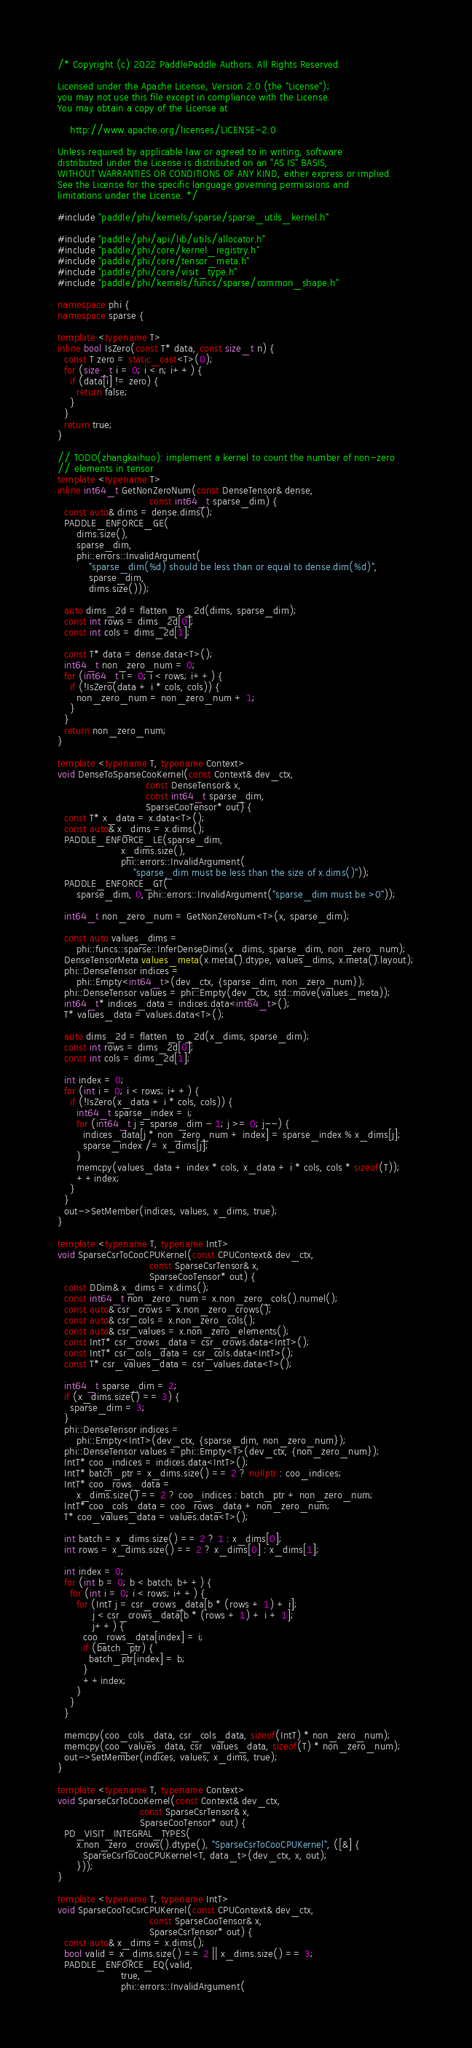<code> <loc_0><loc_0><loc_500><loc_500><_C++_>/* Copyright (c) 2022 PaddlePaddle Authors. All Rights Reserved.

Licensed under the Apache License, Version 2.0 (the "License");
you may not use this file except in compliance with the License.
You may obtain a copy of the License at

    http://www.apache.org/licenses/LICENSE-2.0

Unless required by applicable law or agreed to in writing, software
distributed under the License is distributed on an "AS IS" BASIS,
WITHOUT WARRANTIES OR CONDITIONS OF ANY KIND, either express or implied.
See the License for the specific language governing permissions and
limitations under the License. */

#include "paddle/phi/kernels/sparse/sparse_utils_kernel.h"

#include "paddle/phi/api/lib/utils/allocator.h"
#include "paddle/phi/core/kernel_registry.h"
#include "paddle/phi/core/tensor_meta.h"
#include "paddle/phi/core/visit_type.h"
#include "paddle/phi/kernels/funcs/sparse/common_shape.h"

namespace phi {
namespace sparse {

template <typename T>
inline bool IsZero(const T* data, const size_t n) {
  const T zero = static_cast<T>(0);
  for (size_t i = 0; i < n; i++) {
    if (data[i] != zero) {
      return false;
    }
  }
  return true;
}

// TODO(zhangkaihuo): implement a kernel to count the number of non-zero
// elements in tensor
template <typename T>
inline int64_t GetNonZeroNum(const DenseTensor& dense,
                             const int64_t sparse_dim) {
  const auto& dims = dense.dims();
  PADDLE_ENFORCE_GE(
      dims.size(),
      sparse_dim,
      phi::errors::InvalidArgument(
          "sparse_dim(%d) should be less than or equal to dense.dim(%d)",
          sparse_dim,
          dims.size()));

  auto dims_2d = flatten_to_2d(dims, sparse_dim);
  const int rows = dims_2d[0];
  const int cols = dims_2d[1];

  const T* data = dense.data<T>();
  int64_t non_zero_num = 0;
  for (int64_t i = 0; i < rows; i++) {
    if (!IsZero(data + i * cols, cols)) {
      non_zero_num = non_zero_num + 1;
    }
  }
  return non_zero_num;
}

template <typename T, typename Context>
void DenseToSparseCooKernel(const Context& dev_ctx,
                            const DenseTensor& x,
                            const int64_t sparse_dim,
                            SparseCooTensor* out) {
  const T* x_data = x.data<T>();
  const auto& x_dims = x.dims();
  PADDLE_ENFORCE_LE(sparse_dim,
                    x_dims.size(),
                    phi::errors::InvalidArgument(
                        "sparse_dim must be less than the size of x.dims()"));
  PADDLE_ENFORCE_GT(
      sparse_dim, 0, phi::errors::InvalidArgument("sparse_dim must be >0"));

  int64_t non_zero_num = GetNonZeroNum<T>(x, sparse_dim);

  const auto values_dims =
      phi::funcs::sparse::InferDenseDims(x_dims, sparse_dim, non_zero_num);
  DenseTensorMeta values_meta(x.meta().dtype, values_dims, x.meta().layout);
  phi::DenseTensor indices =
      phi::Empty<int64_t>(dev_ctx, {sparse_dim, non_zero_num});
  phi::DenseTensor values = phi::Empty(dev_ctx, std::move(values_meta));
  int64_t* indices_data = indices.data<int64_t>();
  T* values_data = values.data<T>();

  auto dims_2d = flatten_to_2d(x_dims, sparse_dim);
  const int rows = dims_2d[0];
  const int cols = dims_2d[1];

  int index = 0;
  for (int i = 0; i < rows; i++) {
    if (!IsZero(x_data + i * cols, cols)) {
      int64_t sparse_index = i;
      for (int64_t j = sparse_dim - 1; j >= 0; j--) {
        indices_data[j * non_zero_num + index] = sparse_index % x_dims[j];
        sparse_index /= x_dims[j];
      }
      memcpy(values_data + index * cols, x_data + i * cols, cols * sizeof(T));
      ++index;
    }
  }
  out->SetMember(indices, values, x_dims, true);
}

template <typename T, typename IntT>
void SparseCsrToCooCPUKernel(const CPUContext& dev_ctx,
                             const SparseCsrTensor& x,
                             SparseCooTensor* out) {
  const DDim& x_dims = x.dims();
  const int64_t non_zero_num = x.non_zero_cols().numel();
  const auto& csr_crows = x.non_zero_crows();
  const auto& csr_cols = x.non_zero_cols();
  const auto& csr_values = x.non_zero_elements();
  const IntT* csr_crows_data = csr_crows.data<IntT>();
  const IntT* csr_cols_data = csr_cols.data<IntT>();
  const T* csr_values_data = csr_values.data<T>();

  int64_t sparse_dim = 2;
  if (x_dims.size() == 3) {
    sparse_dim = 3;
  }
  phi::DenseTensor indices =
      phi::Empty<IntT>(dev_ctx, {sparse_dim, non_zero_num});
  phi::DenseTensor values = phi::Empty<T>(dev_ctx, {non_zero_num});
  IntT* coo_indices = indices.data<IntT>();
  IntT* batch_ptr = x_dims.size() == 2 ? nullptr : coo_indices;
  IntT* coo_rows_data =
      x_dims.size() == 2 ? coo_indices : batch_ptr + non_zero_num;
  IntT* coo_cols_data = coo_rows_data + non_zero_num;
  T* coo_values_data = values.data<T>();

  int batch = x_dims.size() == 2 ? 1 : x_dims[0];
  int rows = x_dims.size() == 2 ? x_dims[0] : x_dims[1];

  int index = 0;
  for (int b = 0; b < batch; b++) {
    for (int i = 0; i < rows; i++) {
      for (IntT j = csr_crows_data[b * (rows + 1) + i];
           j < csr_crows_data[b * (rows + 1) + i + 1];
           j++) {
        coo_rows_data[index] = i;
        if (batch_ptr) {
          batch_ptr[index] = b;
        }
        ++index;
      }
    }
  }

  memcpy(coo_cols_data, csr_cols_data, sizeof(IntT) * non_zero_num);
  memcpy(coo_values_data, csr_values_data, sizeof(T) * non_zero_num);
  out->SetMember(indices, values, x_dims, true);
}

template <typename T, typename Context>
void SparseCsrToCooKernel(const Context& dev_ctx,
                          const SparseCsrTensor& x,
                          SparseCooTensor* out) {
  PD_VISIT_INTEGRAL_TYPES(
      x.non_zero_crows().dtype(), "SparseCsrToCooCPUKernel", ([&] {
        SparseCsrToCooCPUKernel<T, data_t>(dev_ctx, x, out);
      }));
}

template <typename T, typename IntT>
void SparseCooToCsrCPUKernel(const CPUContext& dev_ctx,
                             const SparseCooTensor& x,
                             SparseCsrTensor* out) {
  const auto& x_dims = x.dims();
  bool valid = x_dims.size() == 2 || x_dims.size() == 3;
  PADDLE_ENFORCE_EQ(valid,
                    true,
                    phi::errors::InvalidArgument(</code> 